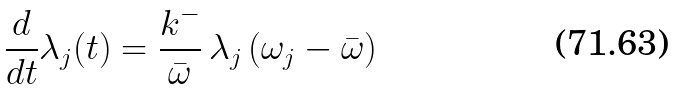Convert formula to latex. <formula><loc_0><loc_0><loc_500><loc_500>\frac { d } { d t } \lambda _ { j } ( t ) = \frac { k ^ { - } } { \bar { \omega } } \, \lambda _ { j } \, ( \omega _ { j } - \bar { \omega } )</formula> 